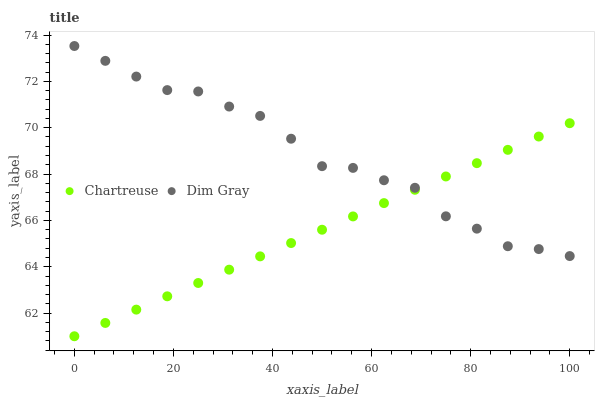Does Chartreuse have the minimum area under the curve?
Answer yes or no. Yes. Does Dim Gray have the maximum area under the curve?
Answer yes or no. Yes. Does Dim Gray have the minimum area under the curve?
Answer yes or no. No. Is Chartreuse the smoothest?
Answer yes or no. Yes. Is Dim Gray the roughest?
Answer yes or no. Yes. Is Dim Gray the smoothest?
Answer yes or no. No. Does Chartreuse have the lowest value?
Answer yes or no. Yes. Does Dim Gray have the lowest value?
Answer yes or no. No. Does Dim Gray have the highest value?
Answer yes or no. Yes. Does Dim Gray intersect Chartreuse?
Answer yes or no. Yes. Is Dim Gray less than Chartreuse?
Answer yes or no. No. Is Dim Gray greater than Chartreuse?
Answer yes or no. No. 